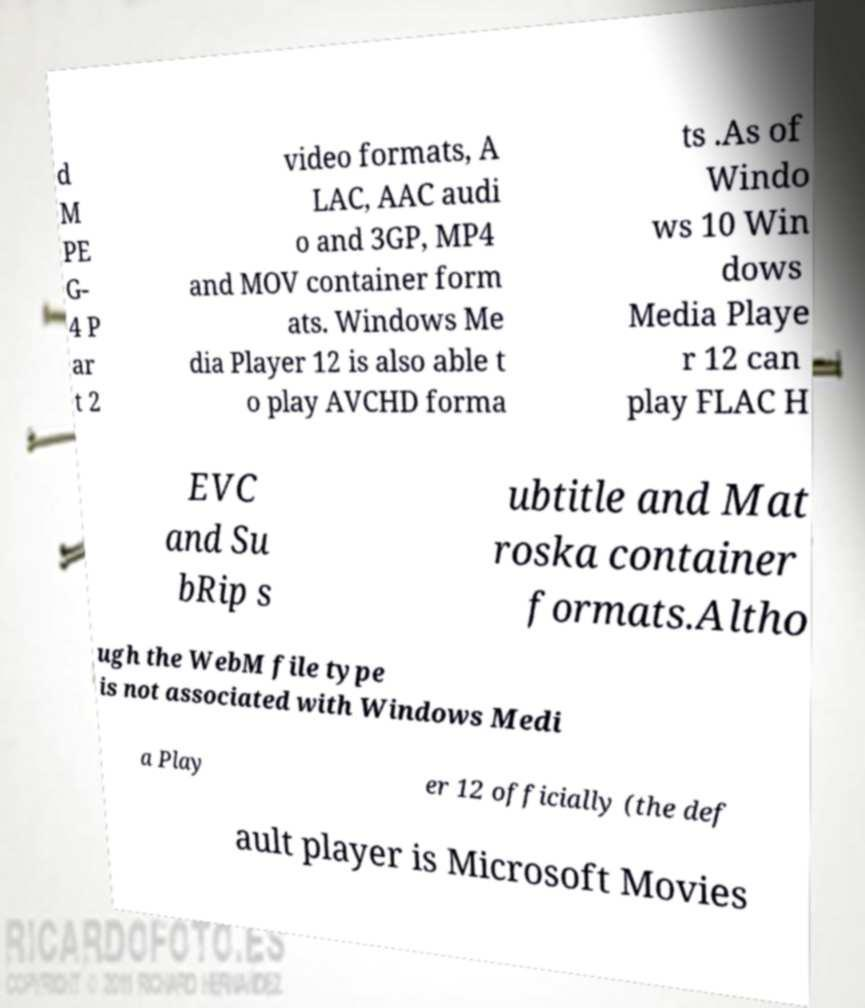Please identify and transcribe the text found in this image. d M PE G- 4 P ar t 2 video formats, A LAC, AAC audi o and 3GP, MP4 and MOV container form ats. Windows Me dia Player 12 is also able t o play AVCHD forma ts .As of Windo ws 10 Win dows Media Playe r 12 can play FLAC H EVC and Su bRip s ubtitle and Mat roska container formats.Altho ugh the WebM file type is not associated with Windows Medi a Play er 12 officially (the def ault player is Microsoft Movies 